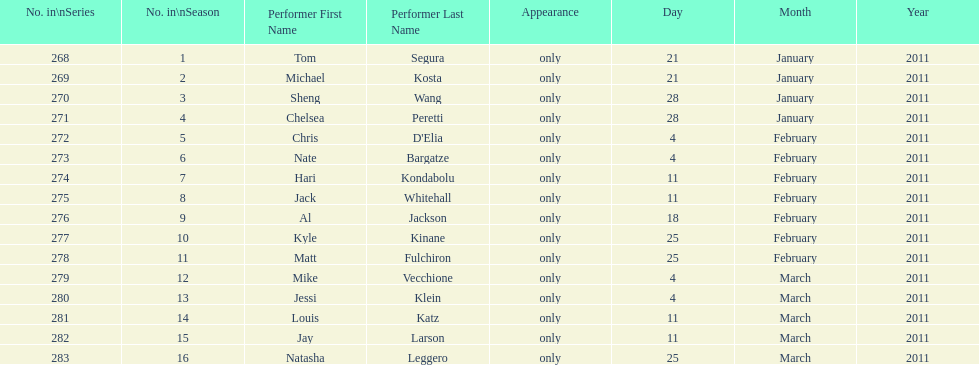Which month had the most air dates? February. 